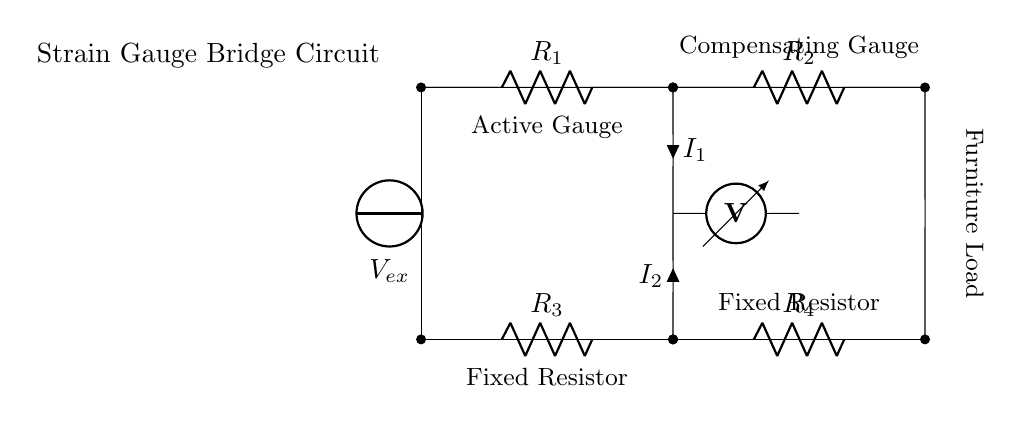What is the total number of resistors in the circuit? There are four resistors in the circuit, labeled R1, R2, R3, and R4. These are used to form the strain gauge bridge.
Answer: 4 What is the function of the voltmeter in this circuit? The voltmeter measures the voltage difference between the two nodes it is connected to. In this case, it measures the voltage across the bridge formed by the resistors.
Answer: Measure voltage What does the 'Vex' source represent? The 'Vex' source represents the excitation voltage that powers the strain gauge bridge circuit. It is necessary for the operation of the device.
Answer: Excitation voltage Why are there both active and compensating gauges indicated? The active gauge is sensitive to strain, while the compensating gauge is used to account for temperature changes or other effects that do not involve strain. This ensures accurate measurements.
Answer: For accuracy What is the purpose of having equal resistors, like R3 and R4? R3 and R4 are often used in a strain gauge bridge to balance the circuit. Equal resistors help achieve a zero output voltage when no strain is present, making it easier to detect changes due to applied loads.
Answer: Balance circuit How is the output of the circuit affected by the strain on the furniture? When the furniture is loaded, the strain gauges change their resistance, creating an imbalance in the bridge. This causes a change in the voltage measured by the voltmeter, indicating the structural integrity.
Answer: Changes voltage 